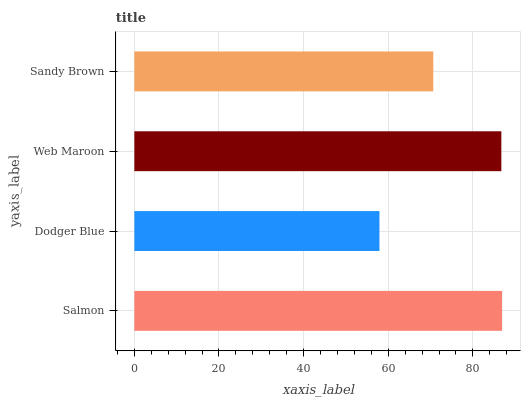Is Dodger Blue the minimum?
Answer yes or no. Yes. Is Salmon the maximum?
Answer yes or no. Yes. Is Web Maroon the minimum?
Answer yes or no. No. Is Web Maroon the maximum?
Answer yes or no. No. Is Web Maroon greater than Dodger Blue?
Answer yes or no. Yes. Is Dodger Blue less than Web Maroon?
Answer yes or no. Yes. Is Dodger Blue greater than Web Maroon?
Answer yes or no. No. Is Web Maroon less than Dodger Blue?
Answer yes or no. No. Is Web Maroon the high median?
Answer yes or no. Yes. Is Sandy Brown the low median?
Answer yes or no. Yes. Is Sandy Brown the high median?
Answer yes or no. No. Is Dodger Blue the low median?
Answer yes or no. No. 